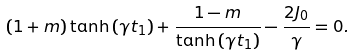<formula> <loc_0><loc_0><loc_500><loc_500>\left ( 1 + m \right ) \tanh \left ( \gamma t _ { 1 } \right ) + \frac { 1 - m } { \tanh \left ( \gamma t _ { 1 } \right ) } - \frac { 2 J _ { 0 } } { \gamma } = 0 .</formula> 